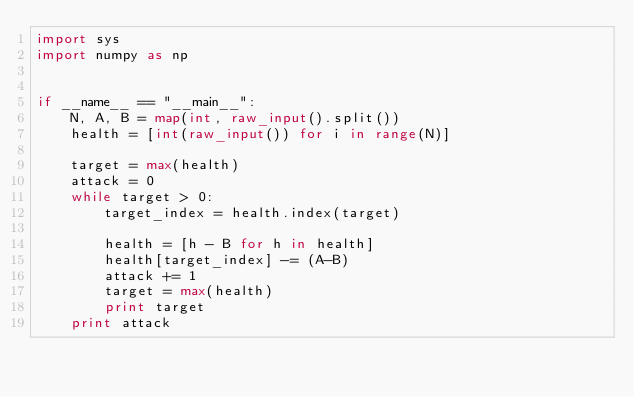Convert code to text. <code><loc_0><loc_0><loc_500><loc_500><_Python_>import sys
import numpy as np


if __name__ == "__main__":
    N, A, B = map(int, raw_input().split())
    health = [int(raw_input()) for i in range(N)]

    target = max(health)
    attack = 0
    while target > 0:
        target_index = health.index(target)

        health = [h - B for h in health]
        health[target_index] -= (A-B)
        attack += 1
        target = max(health)
        print target
    print attack</code> 